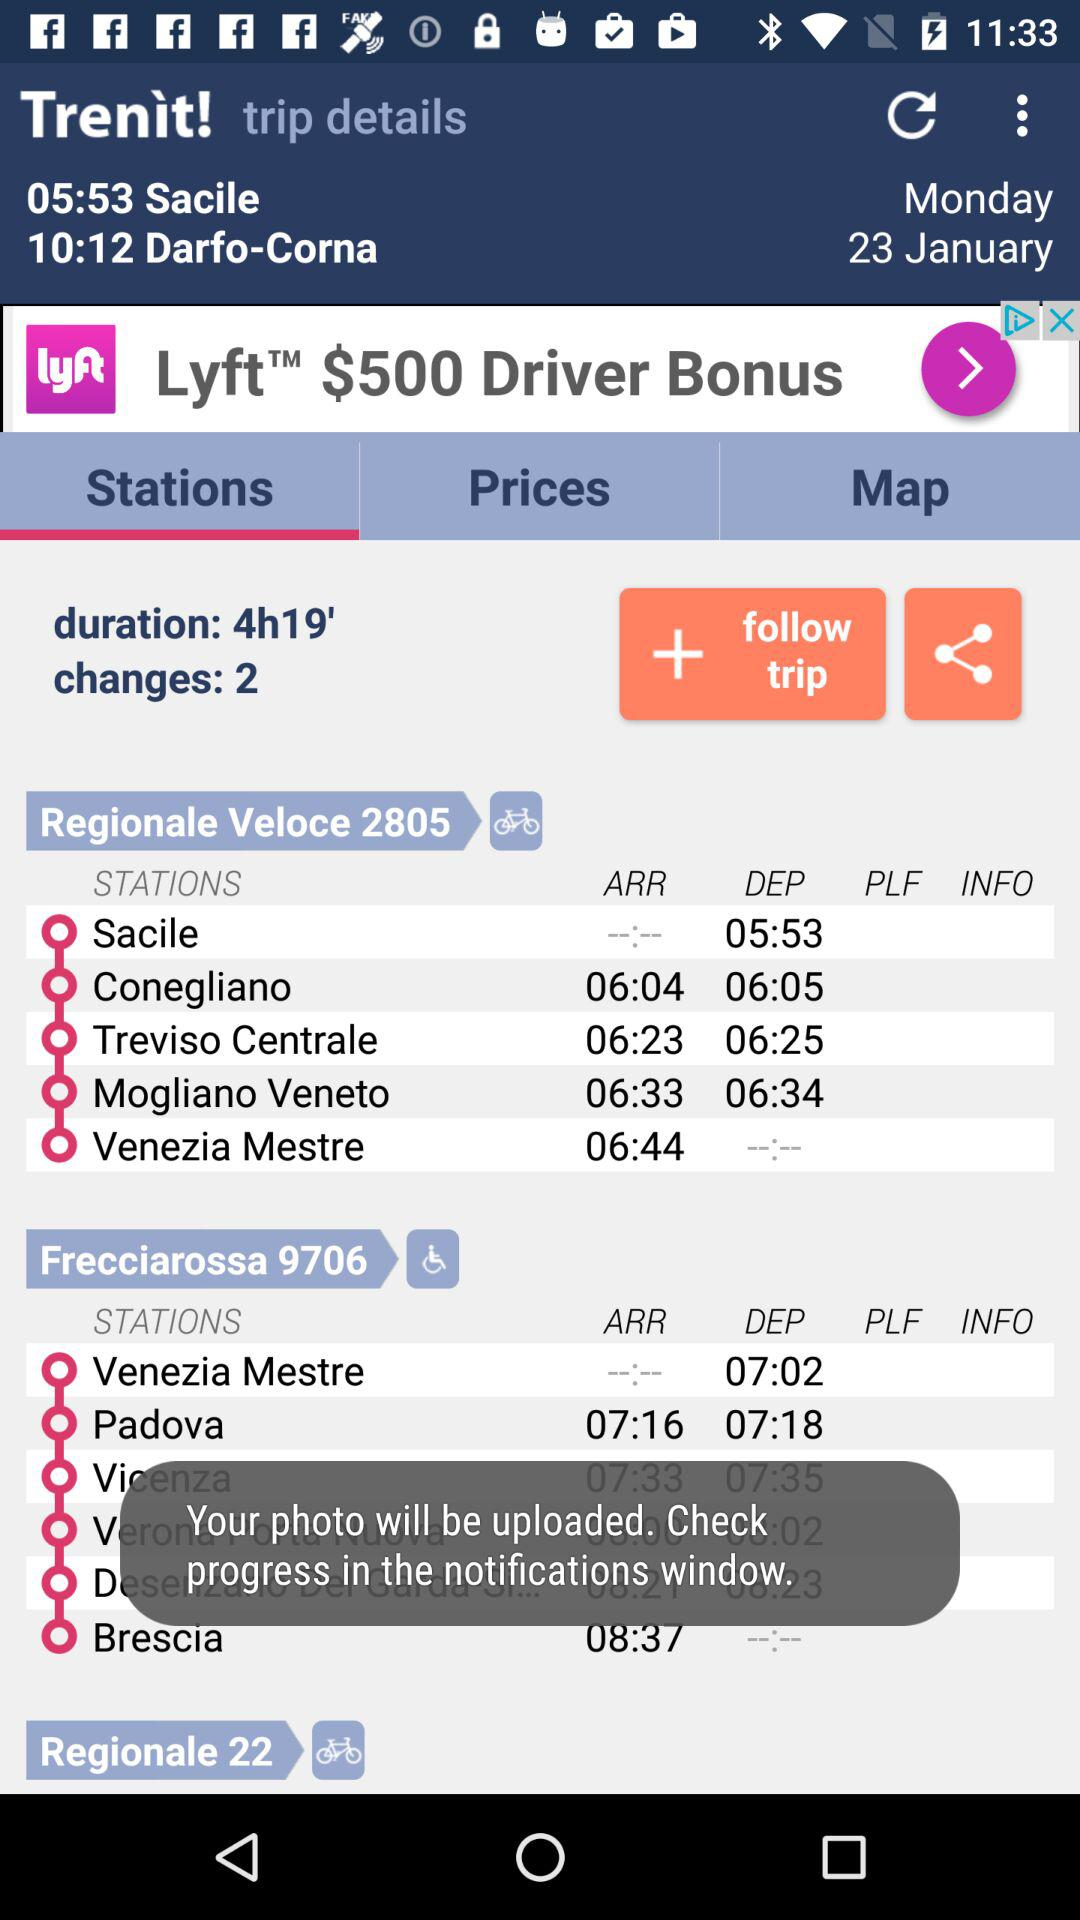From where can the progress be checked? You can check the progress in the notifications window. 